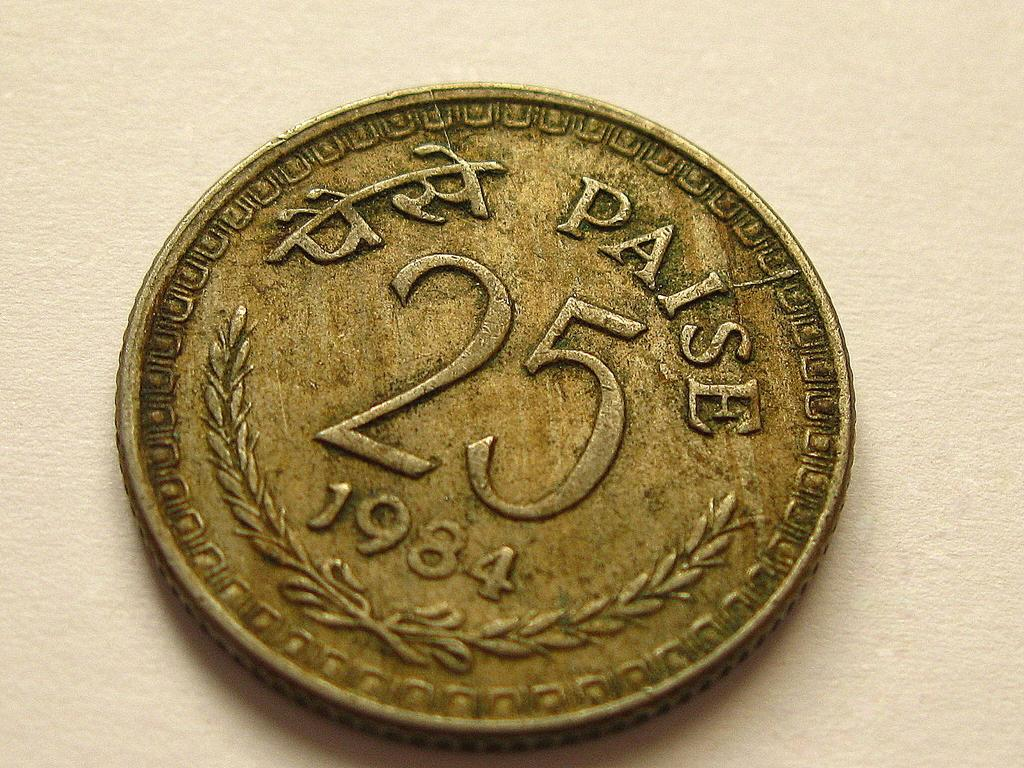<image>
Write a terse but informative summary of the picture. Bronze coin that is labeled 25 Paise in 1984 